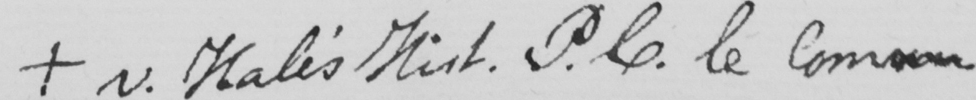Please provide the text content of this handwritten line. +  v . Hale ' s Hist . P.C le Common . 